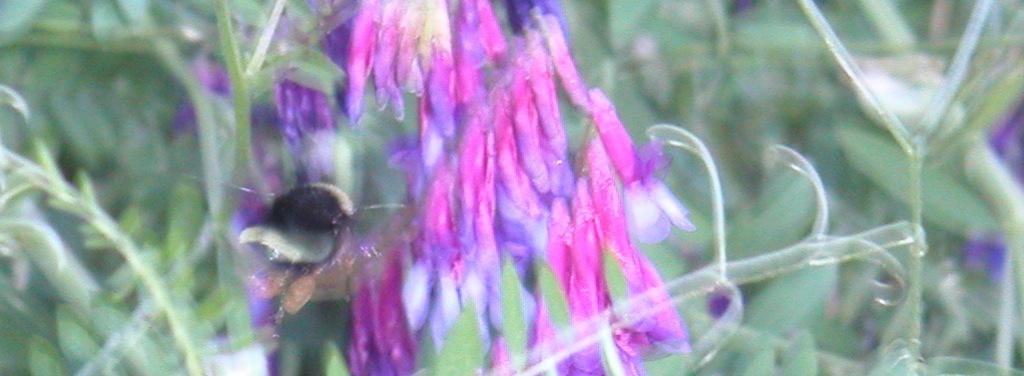What type of plants can be seen in the image? There are flowers in the image. What color is predominant in the background of the image? The background of the image is green. Can you tell me how many strings are attached to the flowers in the image? There are no strings attached to the flowers in the image. Who is the stranger in the image? There is no stranger present in the image. 